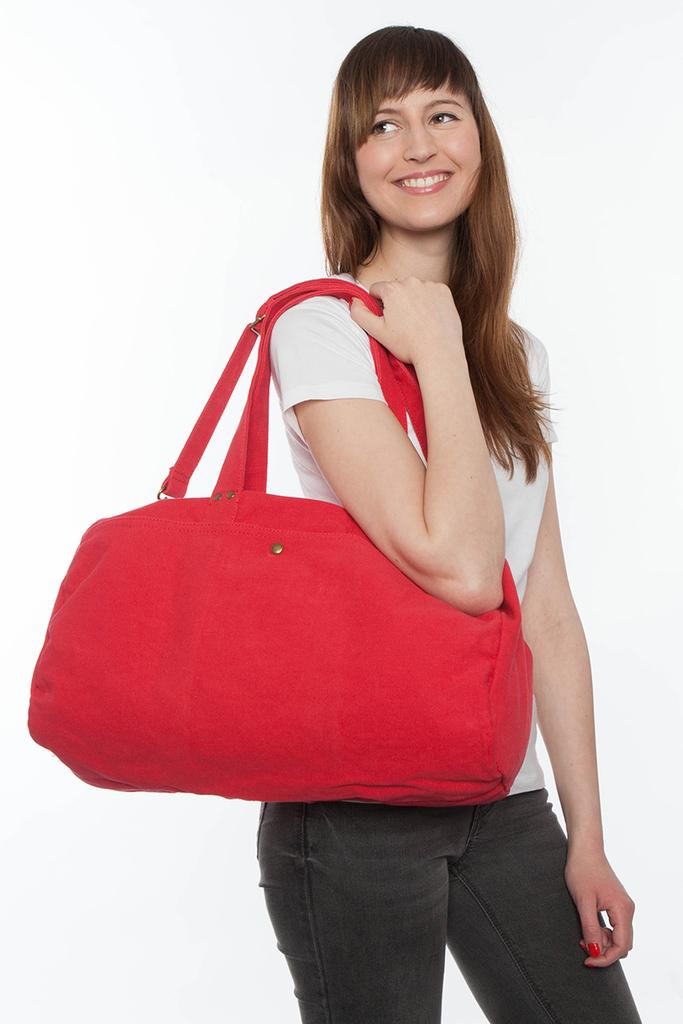What is the gender of the person in the image? There is a woman in the image. What is the woman carrying in the image? The woman is carrying a red bag. What is the woman's facial expression in the image? The woman is smiling. What type of toothpaste is the woman using in the image? There is no toothpaste present in the image; it only shows a woman carrying a red bag and smiling. 